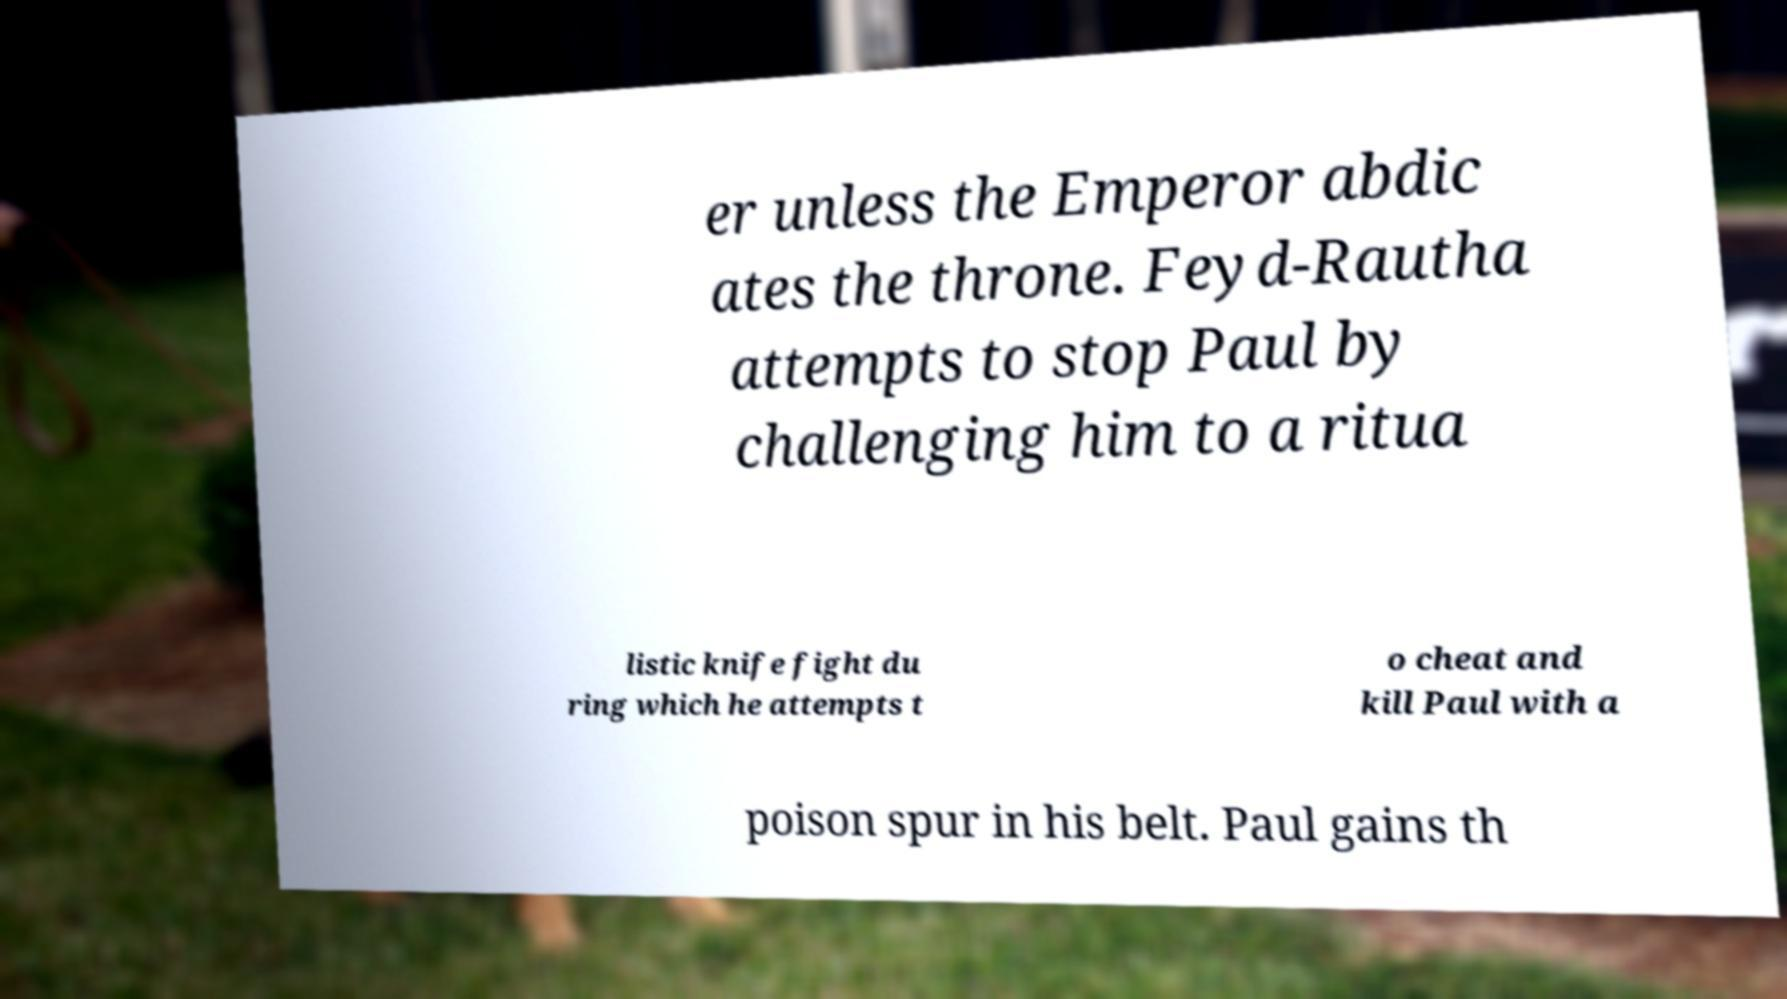Please read and relay the text visible in this image. What does it say? er unless the Emperor abdic ates the throne. Feyd-Rautha attempts to stop Paul by challenging him to a ritua listic knife fight du ring which he attempts t o cheat and kill Paul with a poison spur in his belt. Paul gains th 